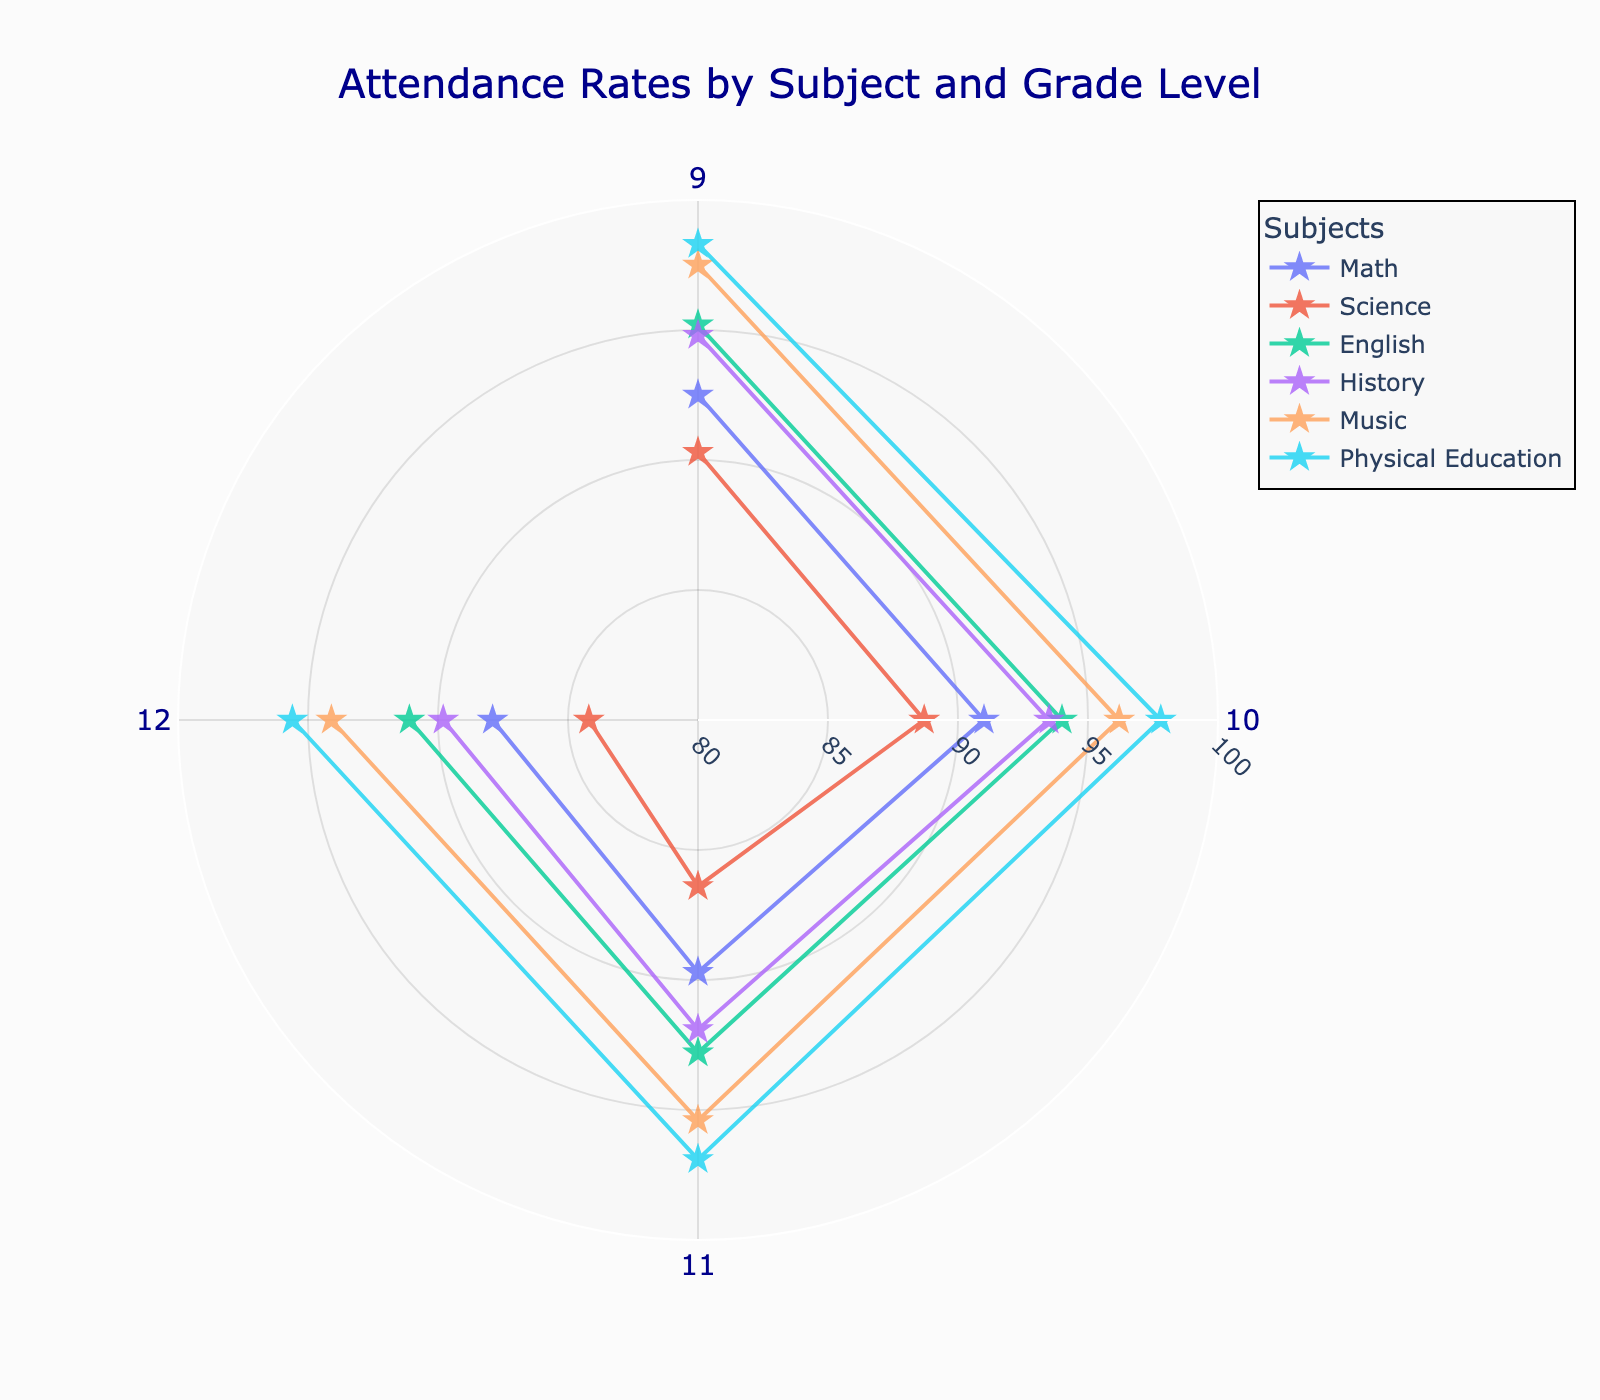What is the title of the chart? The title is located at the top center of the chart in dark blue text.
Answer: Attendance Rates by Subject and Grade Level Which subject has the highest attendance rate for 9th grade? Look at the markers for 9th grade along the angular axis and compare their positions on the radial axis. The marker for Physical Education is placed highest on the radial axis for 9th grade.
Answer: Physical Education How does the attendance rate change from 9th to 12th grade for Math? Identify the markers for Math and observe their positions from 9th to 12th grade. They show a steady decline.
Answer: It decreases What is the average attendance rate for English over all grade levels? Sum the attendance rates for English (95.2, 94.0, 92.8, 91.1) and then divide by the number of grade levels (4).
Answer: (95.2 + 94.0 + 92.8 + 91.1) / 4 = 93.28 Which subject shows the greatest decline in attendance rate from 9th to 12th grade? Calculate the difference in attendance rates for each subject from 9th to 12th grade and compare. The difference for Science (90.3 - 84.2), Math (92.5 - 87.9), English (95.2 - 91.1), History (94.8 - 89.8), Music (97.5 - 94.1), and Physical Education (98.3 - 95.6) shows that Science has the greatest decline.
Answer: Science Which two grade levels have the closest attendance rates for Music? Compare the attendance rates for Music between all pairs of grade levels (9th, 10th, 11th, 12th). The closest rates are for 11th (95.4) and 12th (94.1), with a difference of 1.3.
Answer: 11th and 12th grade What is the range of attendance rates for History? The range is calculated by subtracting the minimum attendance rate for History (89.8) from the maximum (94.8).
Answer: 94.8 - 89.8 = 5.0 How does the attendance rate for Physical Education compare to other subjects in 10th grade? Look at the markers for 10th grade and compare their radial positions. Physical Education's marker is the highest, indicating the highest attendance rate.
Answer: Highest among the subjects What is the median attendance rate for all subjects in 11th grade? Organize the rates for 11th grade (Math: 89.7, Science: 86.4, English: 92.8, History: 91.9, Music: 95.4, Physical Education: 96.9). The median, being the middle value when arranged in order (86.4, 89.7, 91.9, 92.8, 95.4, 96.9), is the average of 91.9 and 92.8.
Answer: (91.9 + 92.8) / 2 = 92.35 In which grade does Math have its lowest attendance rate? Locate Math's attendance rates for each grade and identify the lowest value, which is in 12th grade (87.9).
Answer: 12th grade 